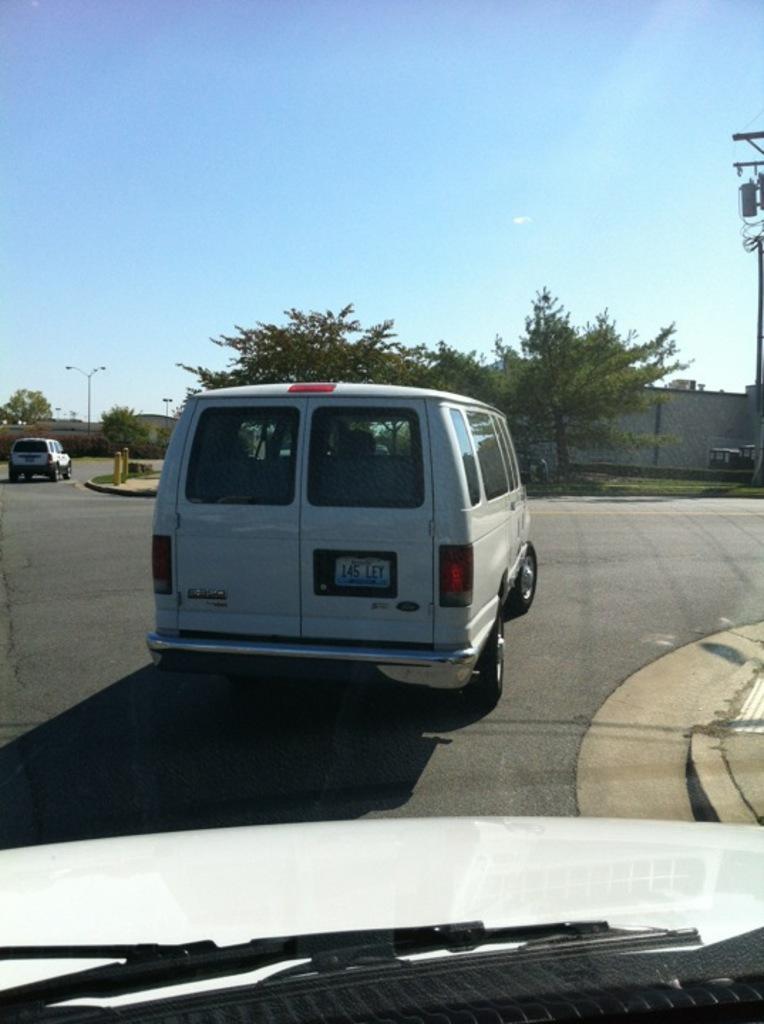In one or two sentences, can you explain what this image depicts? In this picture we can see the view from the car windshield glass. Behind there is a see silver color van on the road. In the background there are some trees and white color boundary wall. 